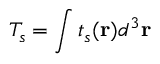<formula> <loc_0><loc_0><loc_500><loc_500>T _ { s } = \int t _ { s } ( r ) d ^ { 3 } r</formula> 